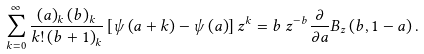Convert formula to latex. <formula><loc_0><loc_0><loc_500><loc_500>\sum _ { k = 0 } ^ { \infty } \frac { \left ( a \right ) _ { k } \left ( b \right ) _ { k } } { k ! \left ( b + 1 \right ) _ { k } } \left [ \psi \left ( a + k \right ) - \psi \left ( a \right ) \right ] z ^ { k } = b \, z ^ { - b } \frac { \partial } { \partial a } B _ { z } \left ( b , 1 - a \right ) .</formula> 